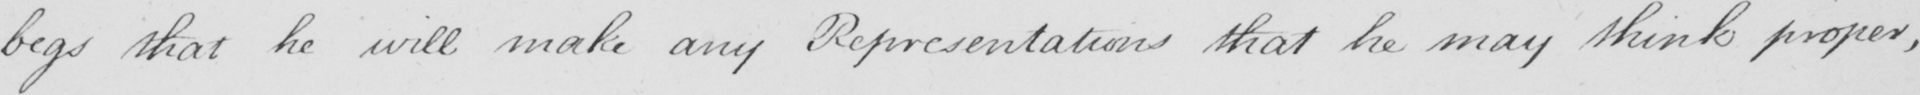Please provide the text content of this handwritten line. begs that he will make any Representations that he may think proper , 